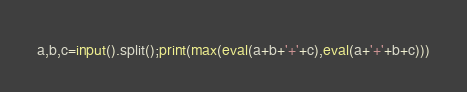Convert code to text. <code><loc_0><loc_0><loc_500><loc_500><_Python_>a,b,c=input().split();print(max(eval(a+b+'+'+c),eval(a+'+'+b+c)))</code> 